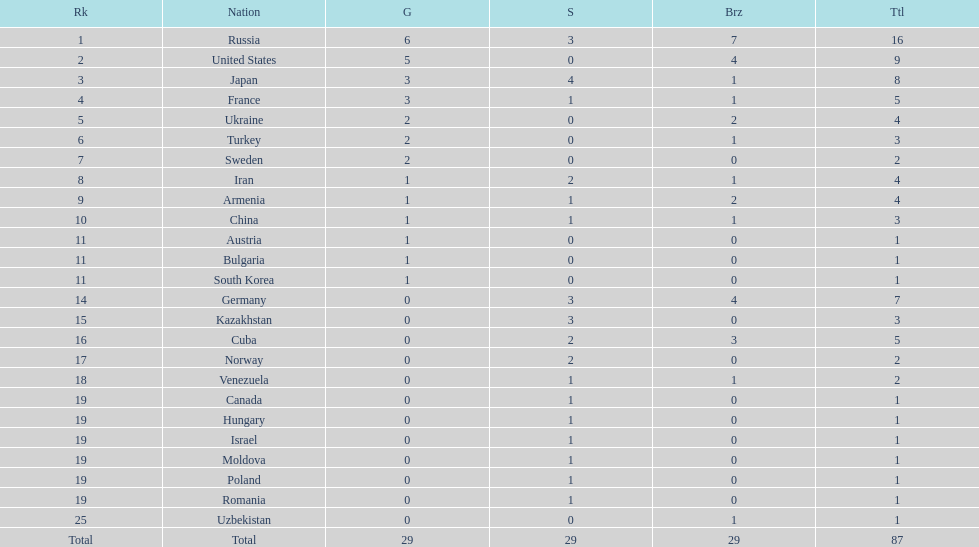Who ranked right after turkey? Sweden. 